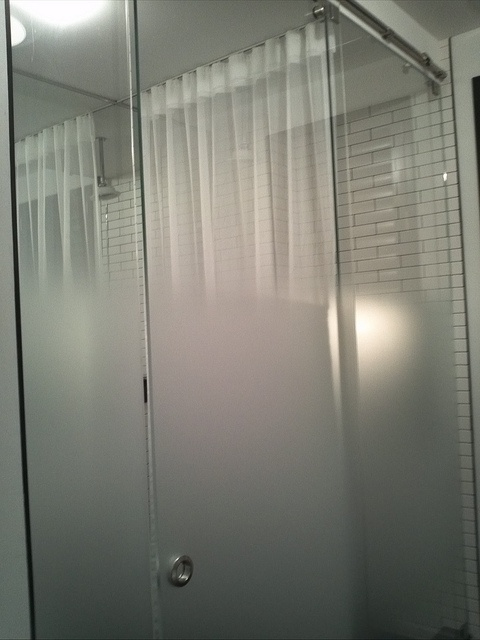Describe the objects in this image and their specific colors. I can see various objects in this image with different colors. 